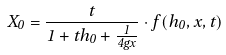Convert formula to latex. <formula><loc_0><loc_0><loc_500><loc_500>X _ { 0 } = \frac { t } { 1 + t h _ { 0 } + \frac { 1 } { 4 g x } } \cdot f ( h _ { 0 } , x , t )</formula> 